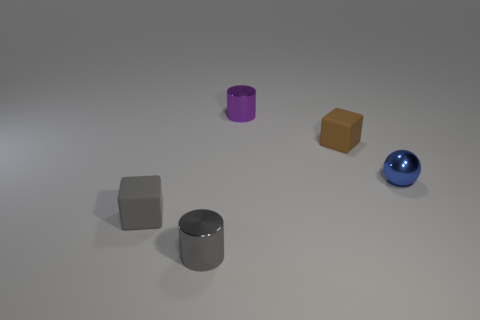What is the color of the other small thing that is the same shape as the gray matte thing?
Make the answer very short. Brown. There is a small shiny cylinder behind the tiny gray cylinder; are there any tiny cylinders that are behind it?
Provide a short and direct response. No. The blue object is what size?
Keep it short and to the point. Small. The tiny metallic thing that is in front of the tiny purple cylinder and on the left side of the tiny brown rubber block has what shape?
Keep it short and to the point. Cylinder. How many cyan things are matte objects or spheres?
Keep it short and to the point. 0. Is the size of the cube to the left of the brown matte object the same as the rubber thing behind the blue shiny thing?
Offer a very short reply. Yes. What number of objects are gray metal things or big blue matte cubes?
Offer a very short reply. 1. Is there another blue object of the same shape as the tiny blue object?
Your answer should be compact. No. Are there fewer purple metallic cylinders than metallic cylinders?
Provide a succinct answer. Yes. Do the brown matte object and the small gray rubber thing have the same shape?
Offer a terse response. Yes. 